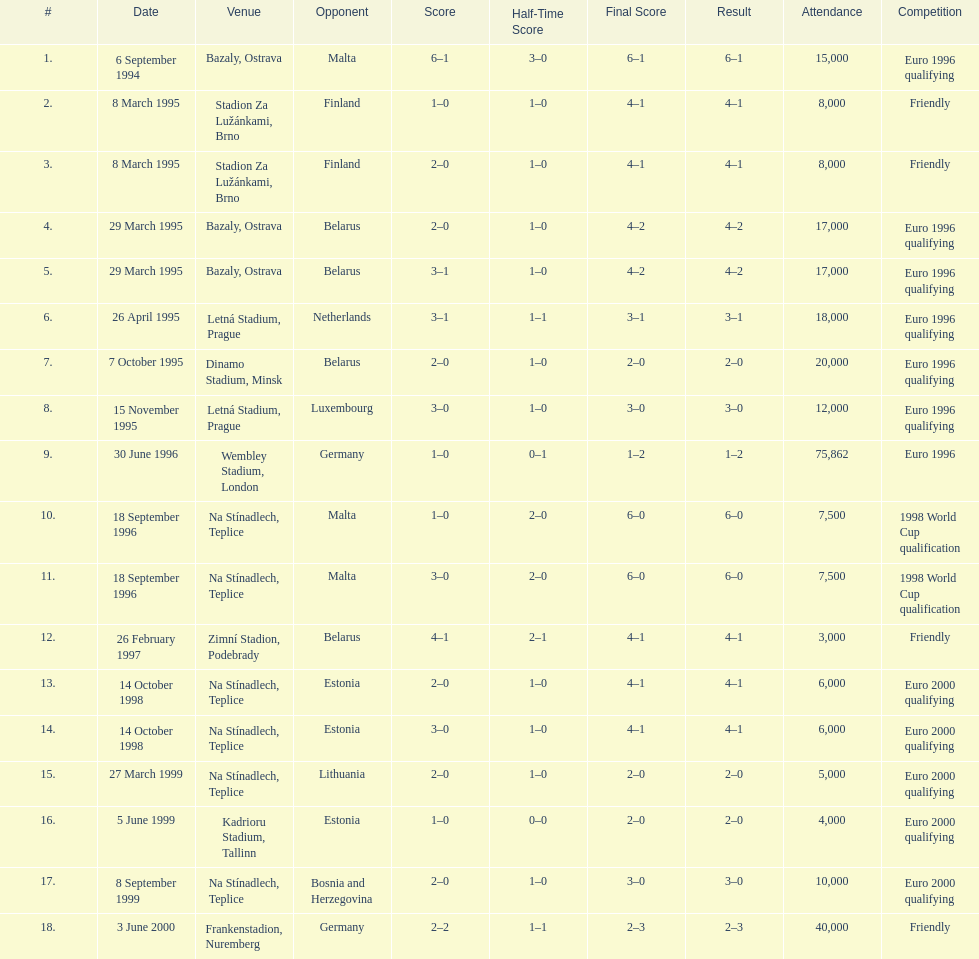What venue is listed above wembley stadium, london? Letná Stadium, Prague. 